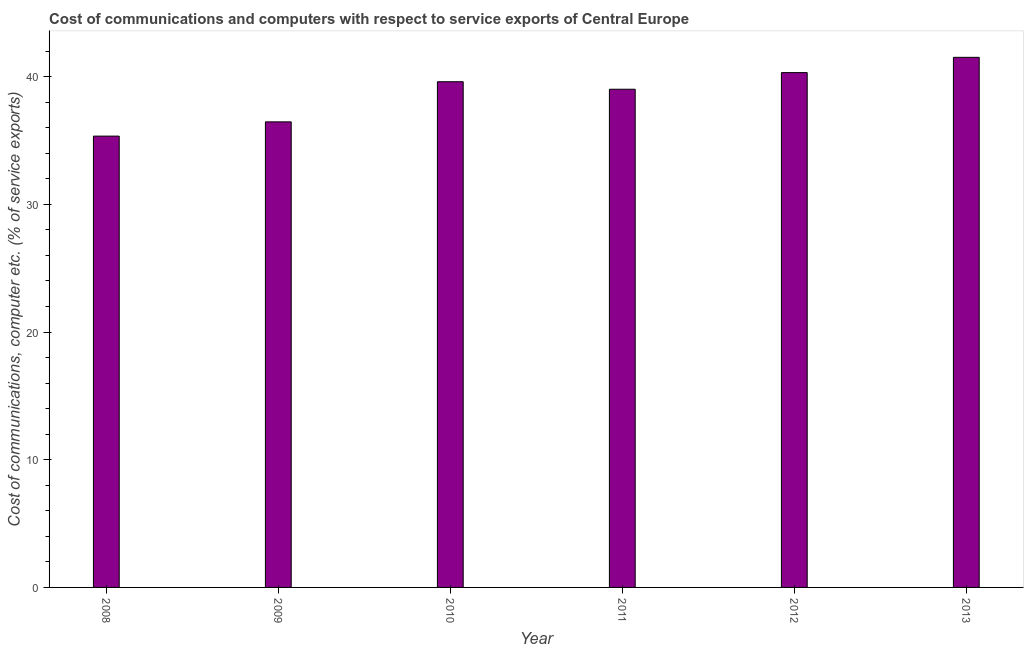Does the graph contain grids?
Provide a succinct answer. No. What is the title of the graph?
Keep it short and to the point. Cost of communications and computers with respect to service exports of Central Europe. What is the label or title of the Y-axis?
Make the answer very short. Cost of communications, computer etc. (% of service exports). What is the cost of communications and computer in 2011?
Offer a very short reply. 39.01. Across all years, what is the maximum cost of communications and computer?
Offer a very short reply. 41.51. Across all years, what is the minimum cost of communications and computer?
Make the answer very short. 35.34. In which year was the cost of communications and computer maximum?
Provide a succinct answer. 2013. In which year was the cost of communications and computer minimum?
Provide a succinct answer. 2008. What is the sum of the cost of communications and computer?
Your answer should be compact. 232.23. What is the difference between the cost of communications and computer in 2011 and 2012?
Offer a very short reply. -1.3. What is the average cost of communications and computer per year?
Keep it short and to the point. 38.7. What is the median cost of communications and computer?
Your response must be concise. 39.31. What is the ratio of the cost of communications and computer in 2008 to that in 2010?
Give a very brief answer. 0.89. Is the cost of communications and computer in 2009 less than that in 2010?
Provide a short and direct response. Yes. Is the difference between the cost of communications and computer in 2008 and 2011 greater than the difference between any two years?
Ensure brevity in your answer.  No. What is the difference between the highest and the second highest cost of communications and computer?
Your response must be concise. 1.2. What is the difference between the highest and the lowest cost of communications and computer?
Give a very brief answer. 6.17. What is the difference between two consecutive major ticks on the Y-axis?
Make the answer very short. 10. What is the Cost of communications, computer etc. (% of service exports) in 2008?
Offer a terse response. 35.34. What is the Cost of communications, computer etc. (% of service exports) of 2009?
Offer a very short reply. 36.46. What is the Cost of communications, computer etc. (% of service exports) in 2010?
Your answer should be compact. 39.6. What is the Cost of communications, computer etc. (% of service exports) of 2011?
Keep it short and to the point. 39.01. What is the Cost of communications, computer etc. (% of service exports) in 2012?
Your answer should be very brief. 40.31. What is the Cost of communications, computer etc. (% of service exports) in 2013?
Your answer should be compact. 41.51. What is the difference between the Cost of communications, computer etc. (% of service exports) in 2008 and 2009?
Ensure brevity in your answer.  -1.12. What is the difference between the Cost of communications, computer etc. (% of service exports) in 2008 and 2010?
Ensure brevity in your answer.  -4.26. What is the difference between the Cost of communications, computer etc. (% of service exports) in 2008 and 2011?
Provide a succinct answer. -3.67. What is the difference between the Cost of communications, computer etc. (% of service exports) in 2008 and 2012?
Your answer should be compact. -4.97. What is the difference between the Cost of communications, computer etc. (% of service exports) in 2008 and 2013?
Give a very brief answer. -6.17. What is the difference between the Cost of communications, computer etc. (% of service exports) in 2009 and 2010?
Your answer should be compact. -3.14. What is the difference between the Cost of communications, computer etc. (% of service exports) in 2009 and 2011?
Ensure brevity in your answer.  -2.55. What is the difference between the Cost of communications, computer etc. (% of service exports) in 2009 and 2012?
Your answer should be very brief. -3.86. What is the difference between the Cost of communications, computer etc. (% of service exports) in 2009 and 2013?
Make the answer very short. -5.05. What is the difference between the Cost of communications, computer etc. (% of service exports) in 2010 and 2011?
Your answer should be very brief. 0.59. What is the difference between the Cost of communications, computer etc. (% of service exports) in 2010 and 2012?
Your answer should be compact. -0.71. What is the difference between the Cost of communications, computer etc. (% of service exports) in 2010 and 2013?
Offer a terse response. -1.91. What is the difference between the Cost of communications, computer etc. (% of service exports) in 2011 and 2012?
Your answer should be very brief. -1.3. What is the difference between the Cost of communications, computer etc. (% of service exports) in 2011 and 2013?
Keep it short and to the point. -2.5. What is the difference between the Cost of communications, computer etc. (% of service exports) in 2012 and 2013?
Keep it short and to the point. -1.2. What is the ratio of the Cost of communications, computer etc. (% of service exports) in 2008 to that in 2009?
Ensure brevity in your answer.  0.97. What is the ratio of the Cost of communications, computer etc. (% of service exports) in 2008 to that in 2010?
Your answer should be compact. 0.89. What is the ratio of the Cost of communications, computer etc. (% of service exports) in 2008 to that in 2011?
Your answer should be compact. 0.91. What is the ratio of the Cost of communications, computer etc. (% of service exports) in 2008 to that in 2012?
Your response must be concise. 0.88. What is the ratio of the Cost of communications, computer etc. (% of service exports) in 2008 to that in 2013?
Ensure brevity in your answer.  0.85. What is the ratio of the Cost of communications, computer etc. (% of service exports) in 2009 to that in 2010?
Your answer should be compact. 0.92. What is the ratio of the Cost of communications, computer etc. (% of service exports) in 2009 to that in 2011?
Provide a short and direct response. 0.94. What is the ratio of the Cost of communications, computer etc. (% of service exports) in 2009 to that in 2012?
Offer a very short reply. 0.9. What is the ratio of the Cost of communications, computer etc. (% of service exports) in 2009 to that in 2013?
Make the answer very short. 0.88. What is the ratio of the Cost of communications, computer etc. (% of service exports) in 2010 to that in 2011?
Offer a terse response. 1.01. What is the ratio of the Cost of communications, computer etc. (% of service exports) in 2010 to that in 2012?
Offer a very short reply. 0.98. What is the ratio of the Cost of communications, computer etc. (% of service exports) in 2010 to that in 2013?
Offer a terse response. 0.95. What is the ratio of the Cost of communications, computer etc. (% of service exports) in 2011 to that in 2013?
Keep it short and to the point. 0.94. What is the ratio of the Cost of communications, computer etc. (% of service exports) in 2012 to that in 2013?
Make the answer very short. 0.97. 